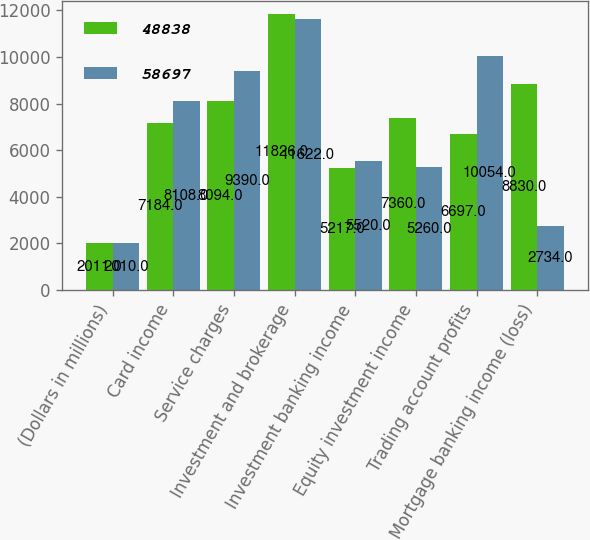Convert chart. <chart><loc_0><loc_0><loc_500><loc_500><stacked_bar_chart><ecel><fcel>(Dollars in millions)<fcel>Card income<fcel>Service charges<fcel>Investment and brokerage<fcel>Investment banking income<fcel>Equity investment income<fcel>Trading account profits<fcel>Mortgage banking income (loss)<nl><fcel>48838<fcel>2011<fcel>7184<fcel>8094<fcel>11826<fcel>5217<fcel>7360<fcel>6697<fcel>8830<nl><fcel>58697<fcel>2010<fcel>8108<fcel>9390<fcel>11622<fcel>5520<fcel>5260<fcel>10054<fcel>2734<nl></chart> 